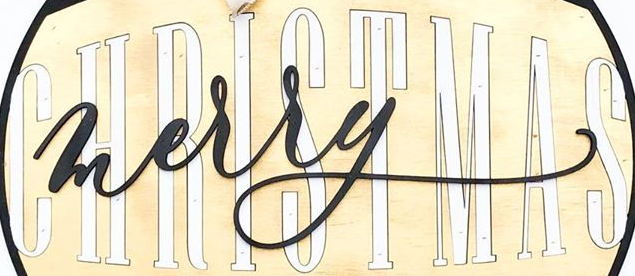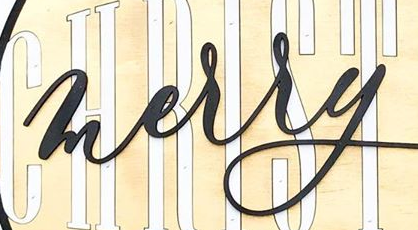Identify the words shown in these images in order, separated by a semicolon. CHRISTMAS; merry 